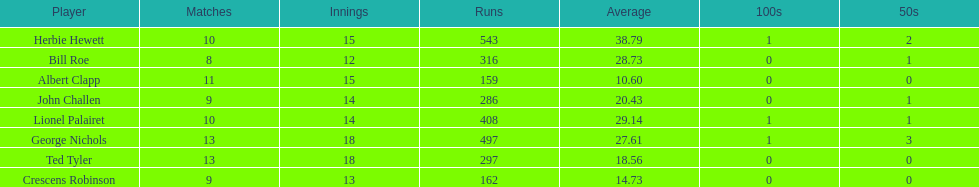Which player had the least amount of runs? Albert Clapp. 